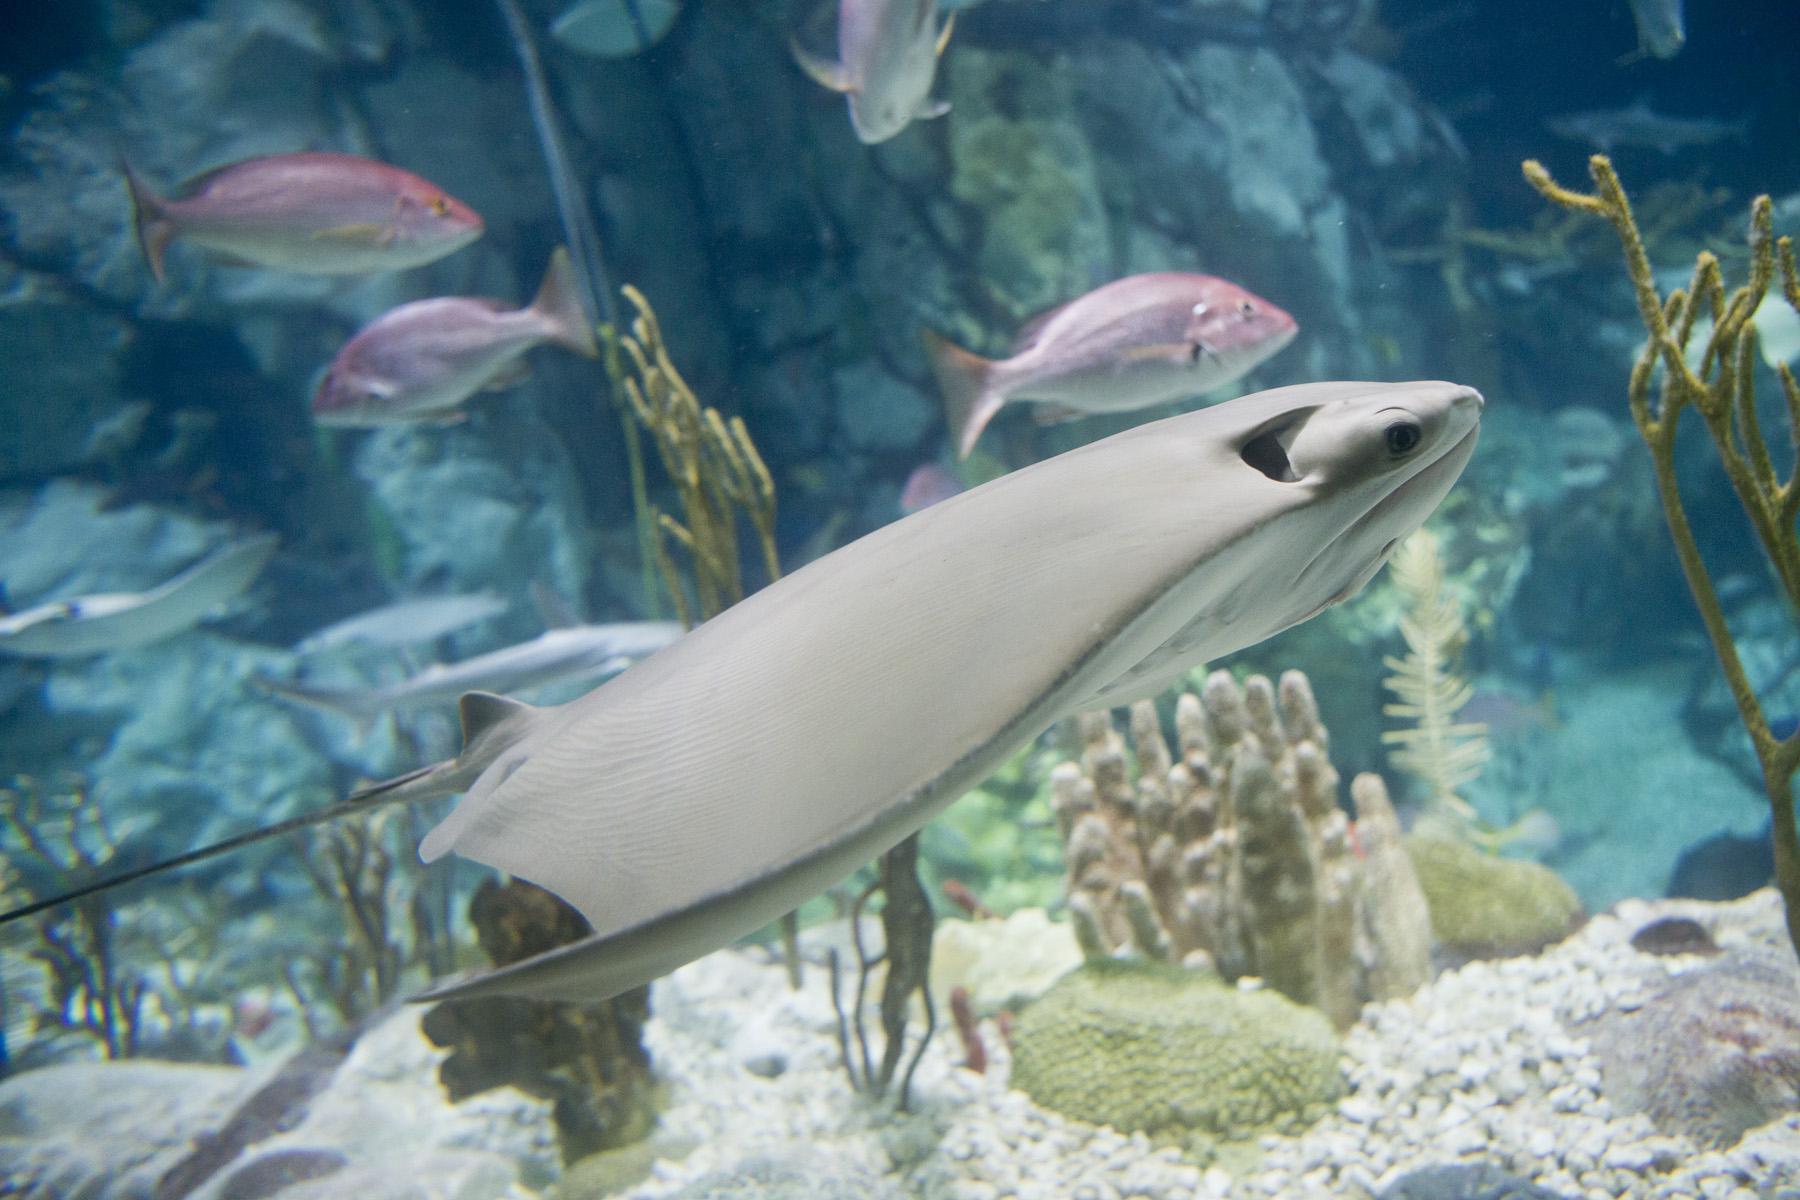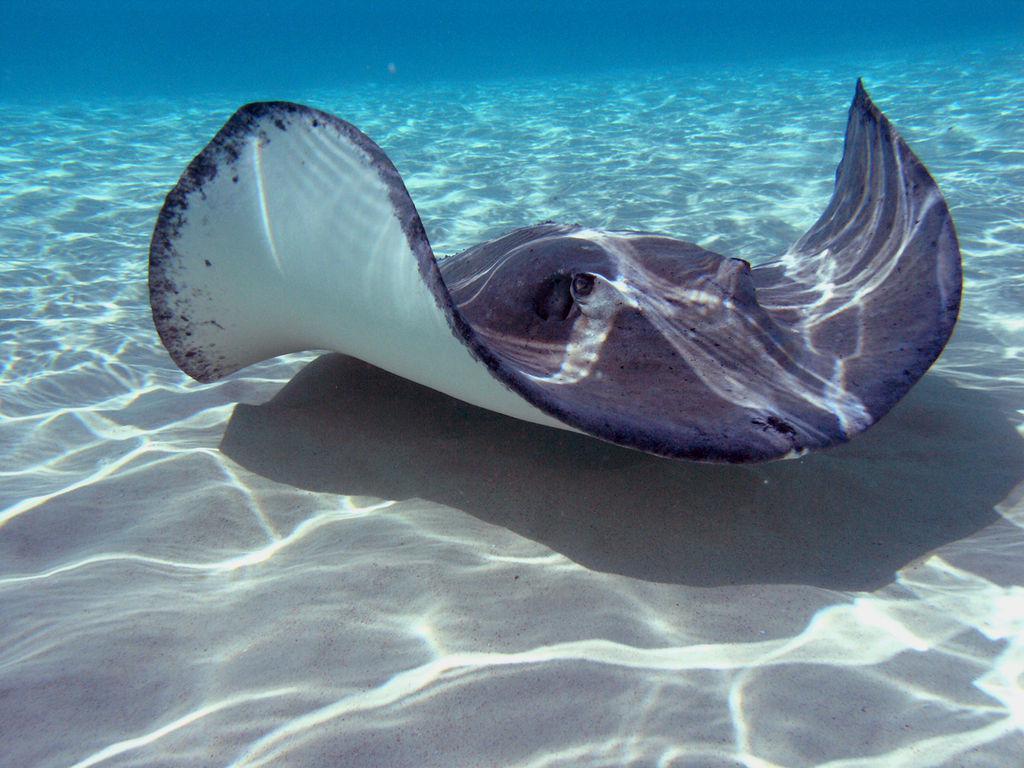The first image is the image on the left, the second image is the image on the right. For the images displayed, is the sentence "At least one of the images displays more than one of the manta rays, who seem to swim in larger groups regularly." factually correct? Answer yes or no. No. The first image is the image on the left, the second image is the image on the right. Assess this claim about the two images: "No image contains more than three stingray in the foreground, and no image contains other types of fish.". Correct or not? Answer yes or no. No. 